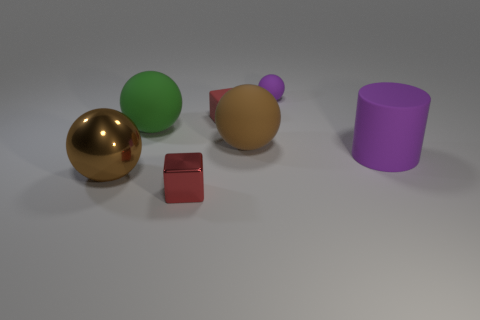Subtract all small purple spheres. How many spheres are left? 3 Subtract all purple balls. How many balls are left? 3 Subtract 1 balls. How many balls are left? 3 Add 1 tiny metallic cubes. How many objects exist? 8 Subtract all cylinders. How many objects are left? 6 Add 6 blocks. How many blocks are left? 8 Add 5 large purple things. How many large purple things exist? 6 Subtract 1 purple balls. How many objects are left? 6 Subtract all blue balls. Subtract all blue blocks. How many balls are left? 4 Subtract all blue blocks. How many yellow spheres are left? 0 